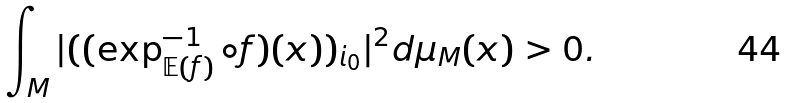Convert formula to latex. <formula><loc_0><loc_0><loc_500><loc_500>\int _ { M } | ( ( \exp _ { \mathbb { E } ( f ) } ^ { - 1 } \circ f ) ( x ) ) _ { i _ { 0 } } | ^ { 2 } d \mu _ { M } ( x ) > 0 .</formula> 